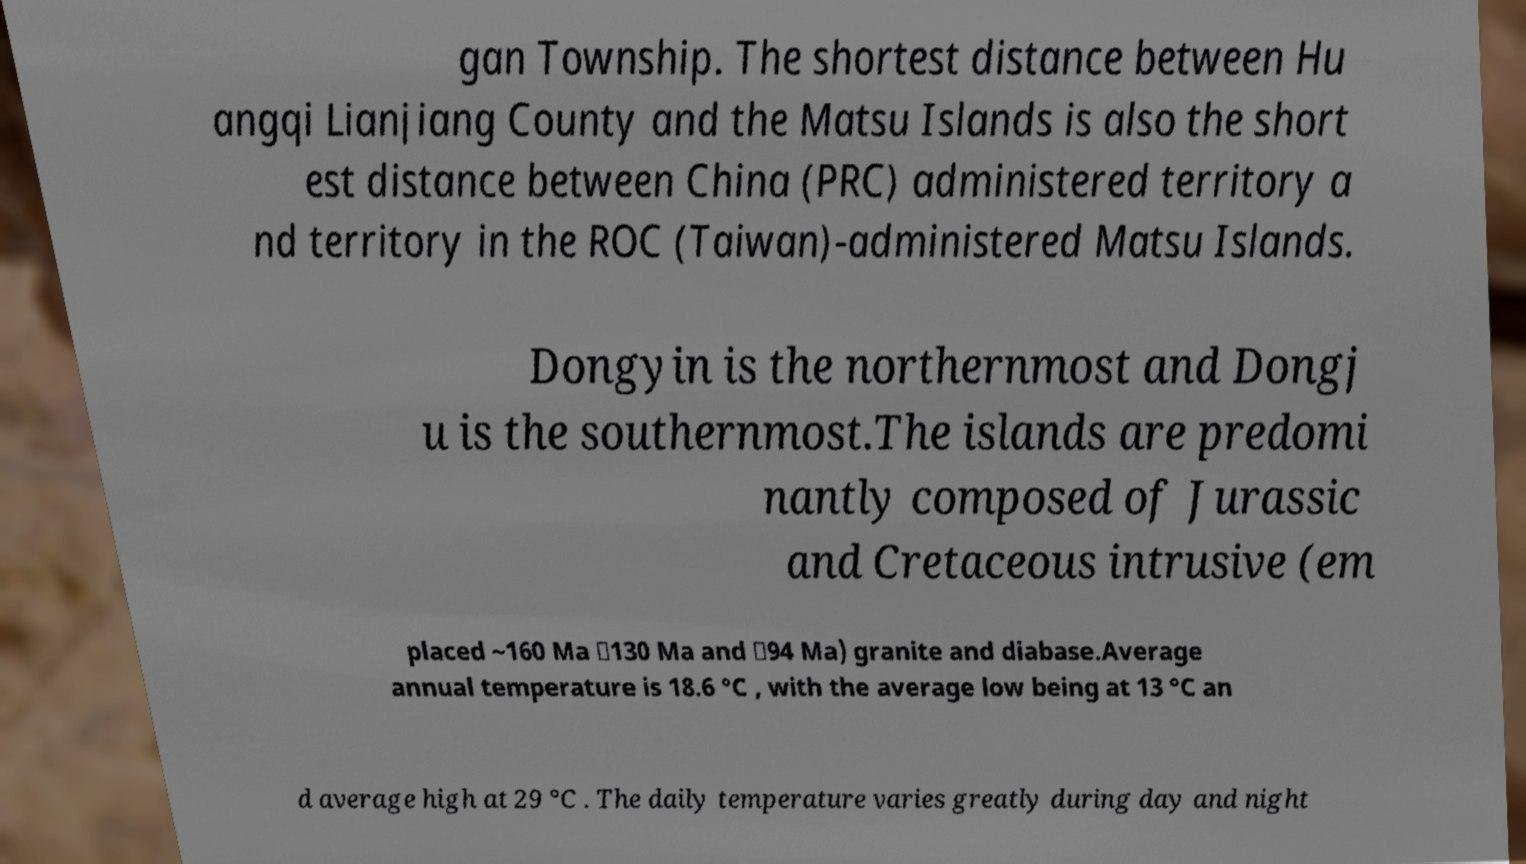Please read and relay the text visible in this image. What does it say? gan Township. The shortest distance between Hu angqi Lianjiang County and the Matsu Islands is also the short est distance between China (PRC) administered territory a nd territory in the ROC (Taiwan)-administered Matsu Islands. Dongyin is the northernmost and Dongj u is the southernmost.The islands are predomi nantly composed of Jurassic and Cretaceous intrusive (em placed ~160 Ma ∼130 Ma and ∼94 Ma) granite and diabase.Average annual temperature is 18.6 °C , with the average low being at 13 °C an d average high at 29 °C . The daily temperature varies greatly during day and night 